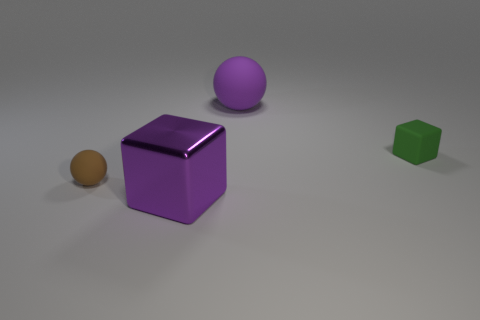Is there any object that reflects light more than the others, and what could that indicate about its surface properties? The purple cube seems to reflect light more intensely than the other objects, indicating that its surface may be glossier and smoother in comparison to the matte finishes on the other objects. 